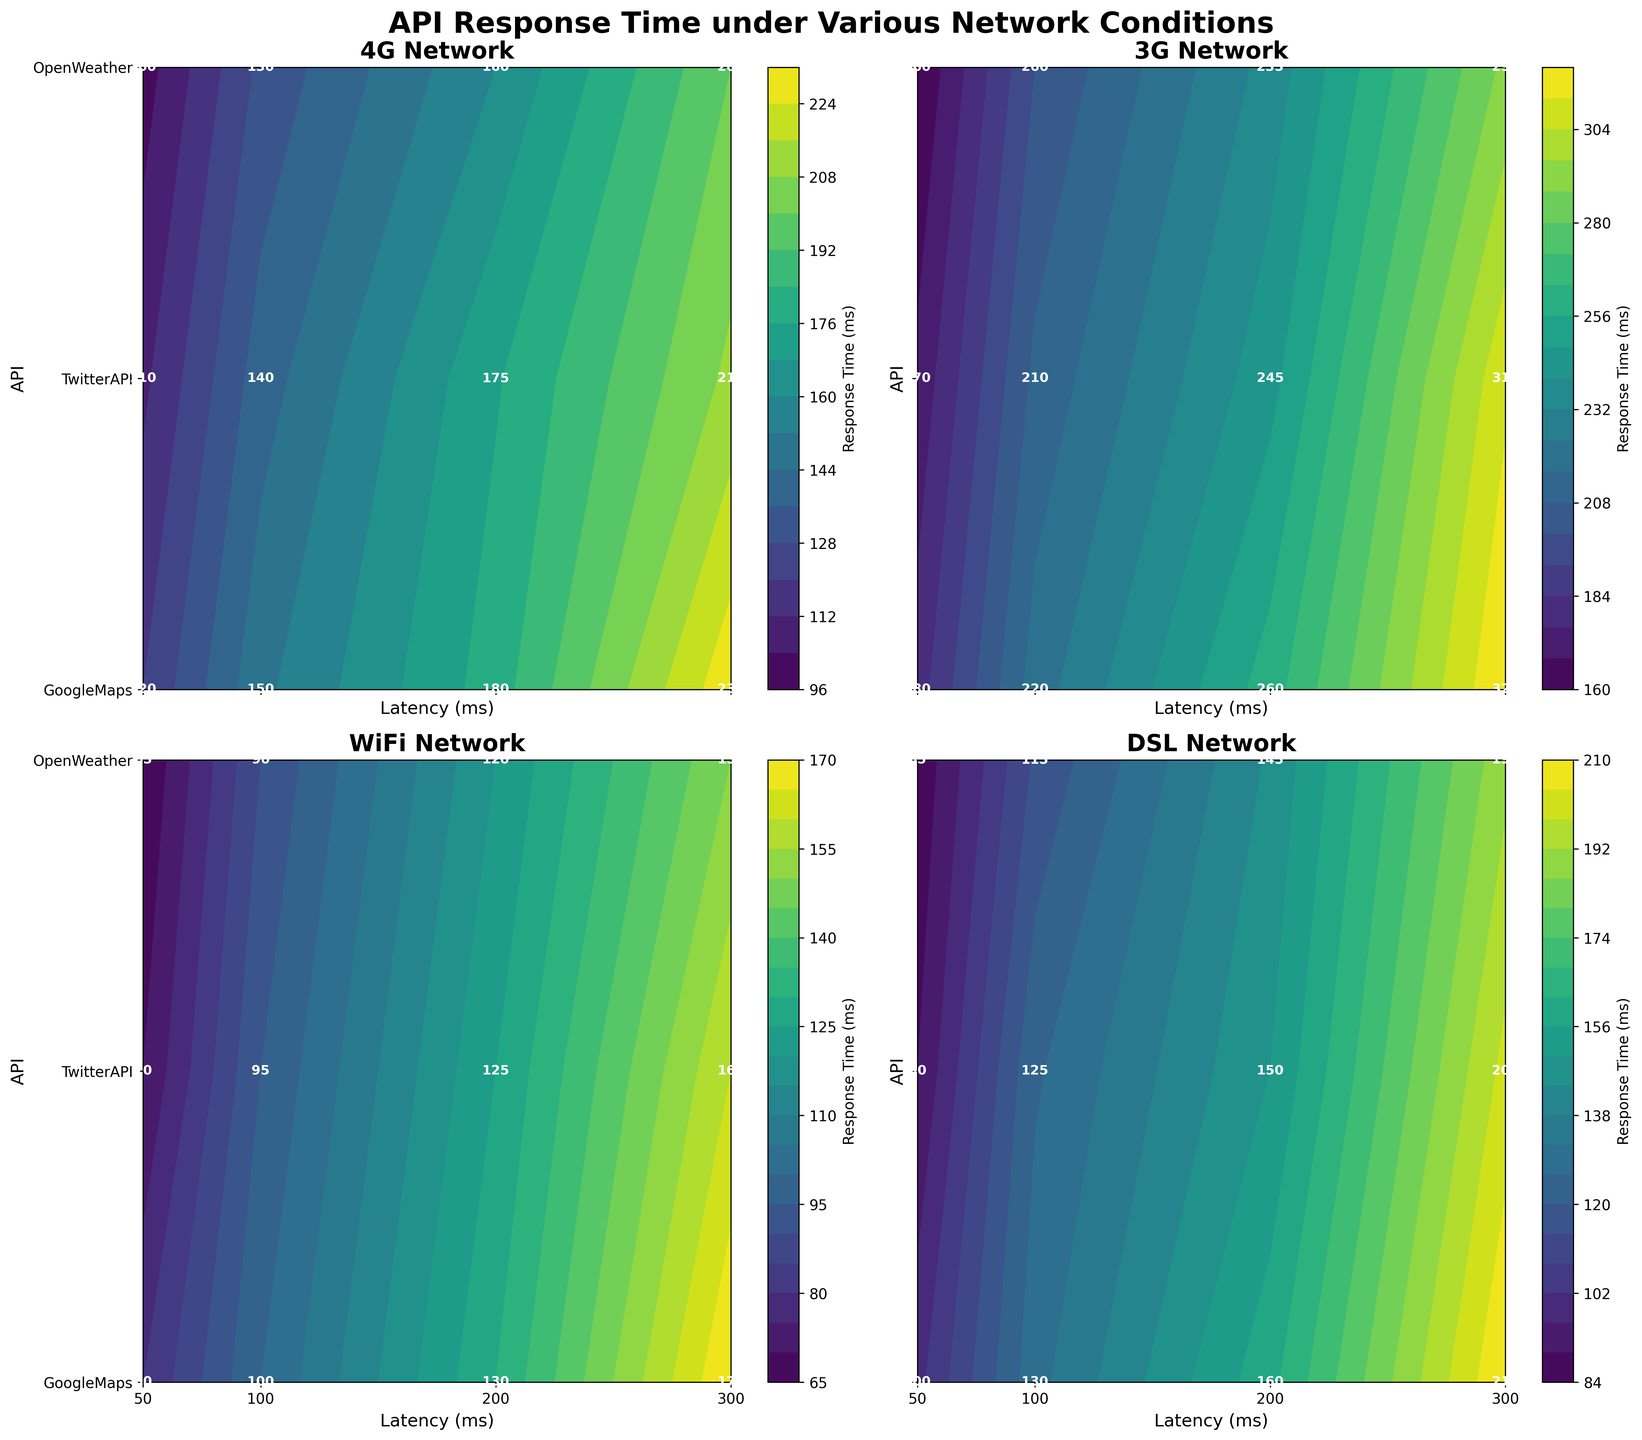What is the title of the figure? The title is typically displayed at the top of the figure and provides a brief description of what the figure represents. In this case, the title is "API Response Time under Various Network Conditions" which is mentioned in the code as 'fig.suptitle'.
Answer: API Response Time under Various Network Conditions Which network condition shows the lowest response time for the GoogleMaps API at 50ms latency? To find this, look at the response times for GoogleMaps API across different network conditions (WiFi, 4G, 3G, DSL) at the 50ms latency point. The response time under WiFi is the lowest at 80ms.
Answer: WiFi On the 3G network, which API has the highest response time at 300ms latency? On the 3G network subplot, check the response times for all APIs (GoogleMaps, TwitterAPI, OpenWeather) at 300ms latency. GoogleMaps has the highest response time of 320ms.
Answer: GoogleMaps For the 4G network condition, what is the difference in response times for the TwitterAPI between 50ms and 100ms latency? Find the response times for TwitterAPI at 50ms latency (110ms) and at 100ms latency (140ms). Calculate the difference: 140ms - 110ms.
Answer: 30ms Which network condition provides the most consistent response times across different latencies for the OpenWeather API? Compare the response times of the OpenWeather API across different latencies (50ms, 100ms, 200ms, 300ms) for each network condition. The WiFi condition shows the most consistency with response times 65ms, 90ms, 120ms, and 150ms.
Answer: WiFi What is the color map used in the figure? By looking at the color scheme of the contour plots and recalling the code, the color scheme is specified as 'viridis', which transitions from dark purple to yellow.
Answer: viridis On the DSL network condition, which API shows the quickest degradation in response time as latency increases from 50ms to 300ms? For DSL, compare how quickly the response times escalate for each API (GoogleMaps, TwitterAPI, OpenWeather). GoogleMaps shows the quickest degradation with an increase from 100ms to 210ms.
Answer: GoogleMaps What is the average response time for the TwitterAPI across all latencies in the WiFi network condition? Sum up the response times for TwitterAPI at 50ms (70ms), 100ms (95ms), 200ms (125ms), and 300ms (160ms), then divide by 4. (70 + 95 + 125 + 160)/4 = 450/4.
Answer: 112.5ms Which API has the highest response time on the WiFi network at 200ms latency? Locate the response times for each API (GoogleMaps, TwitterAPI, OpenWeather) at 200ms latency on the WiFi network subplot. GoogleMaps has the highest response at 130ms.
Answer: GoogleMaps 